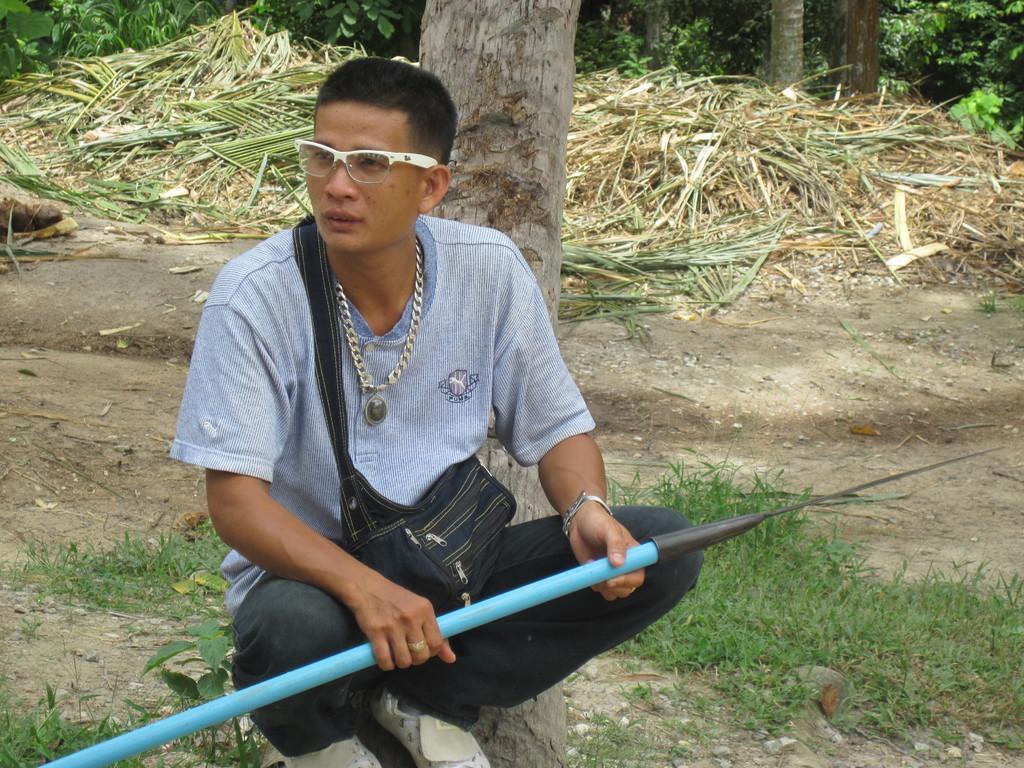Can you describe this image briefly? In this picture there is a man who is wearing spectacle, locket, t-shirt, match, trouser, shoes and bag. He is holding a rod. He is sitting on the stones. In the back I can see the grass, wastage, trees and plants. 